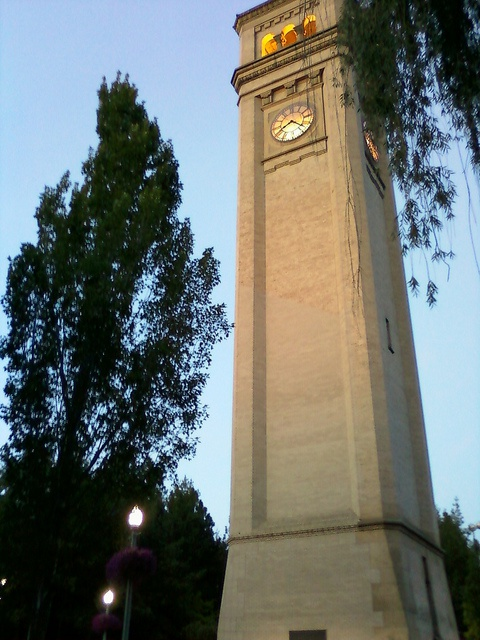Describe the objects in this image and their specific colors. I can see clock in lightblue, gray, khaki, and tan tones and clock in lightblue, maroon, black, and gray tones in this image. 